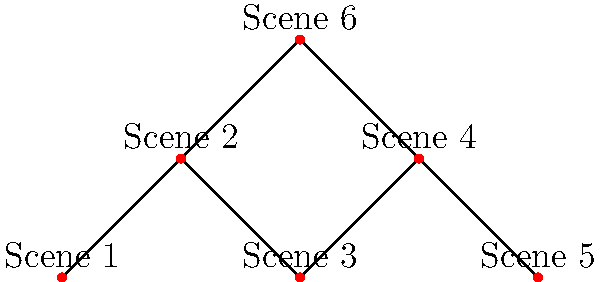In your latest independent film project, you've mapped out the connectivity between different scenes as shown in the graph above. Each node represents a scene, and edges represent direct transitions between scenes. What is the minimum number of scenes that need to be removed to disconnect Scene 1 from Scene 5? To solve this problem, we need to find the minimum cut between Scene 1 and Scene 5. Let's approach this step-by-step:

1. Identify all possible paths from Scene 1 to Scene 5:
   Path 1: Scene 1 → Scene 2 → Scene 3 → Scene 4 → Scene 5
   Path 2: Scene 1 → Scene 2 → Scene 6 → Scene 4 → Scene 5

2. Observe that both paths share Scene 2 and Scene 4.

3. If we remove either Scene 2 or Scene 4, it would disconnect all paths from Scene 1 to Scene 5.

4. Since removing just one scene (either Scene 2 or Scene 4) is sufficient to disconnect Scene 1 from Scene 5, this is the minimum number of scenes that need to be removed.

5. In graph theory terms, this is equivalent to finding the minimum vertex cut between two nodes, which in this case is 1.

Therefore, the minimum number of scenes that need to be removed to disconnect Scene 1 from Scene 5 is 1.
Answer: 1 